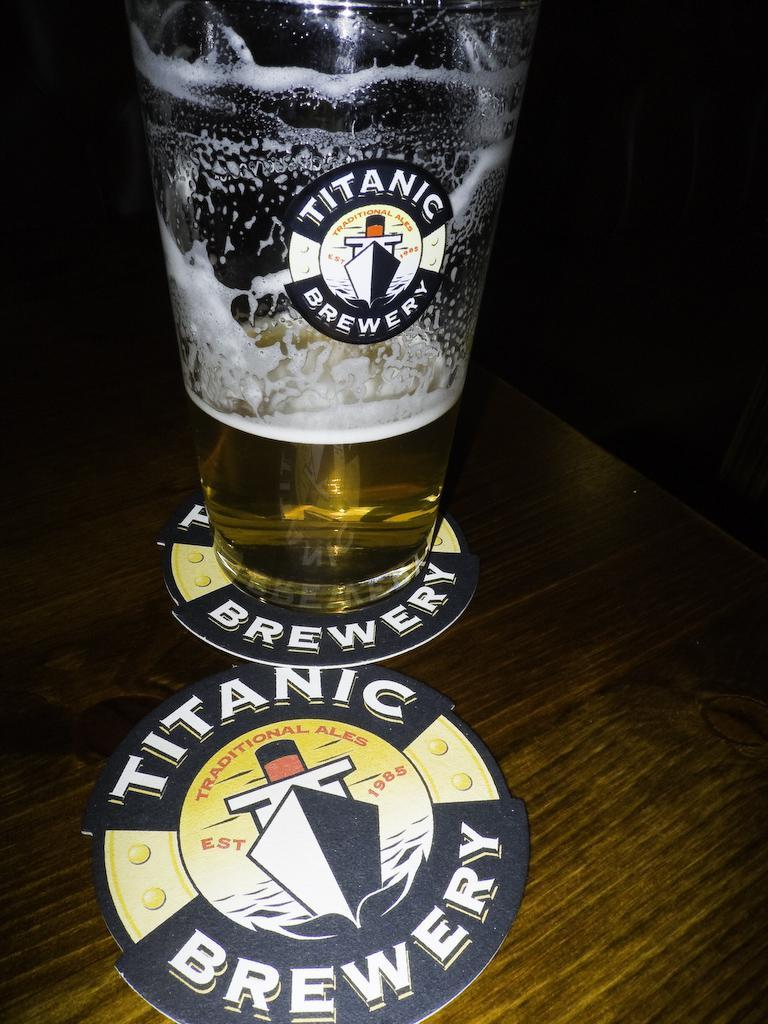<image>
Share a concise interpretation of the image provided. A glass featuring the Titanic Brewery logo is on a coaster. 